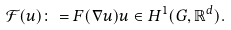<formula> <loc_0><loc_0><loc_500><loc_500>\mathcal { F } ( u ) \colon = F ( \nabla u ) u \in H ^ { 1 } ( G , \mathbb { R } ^ { d } ) .</formula> 